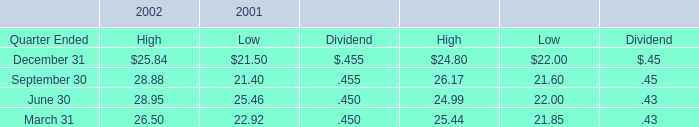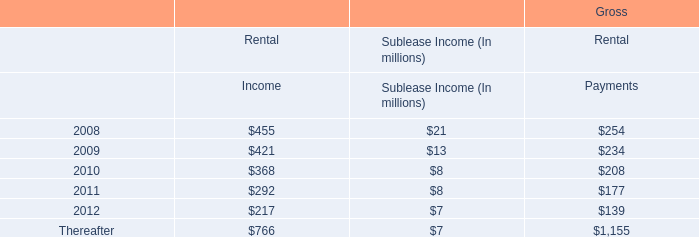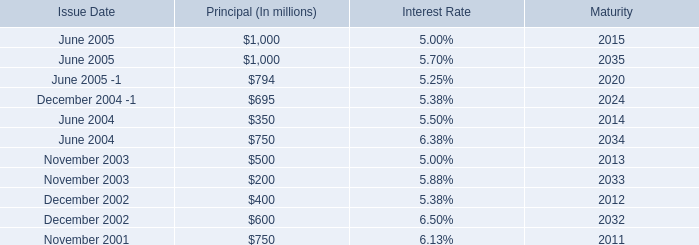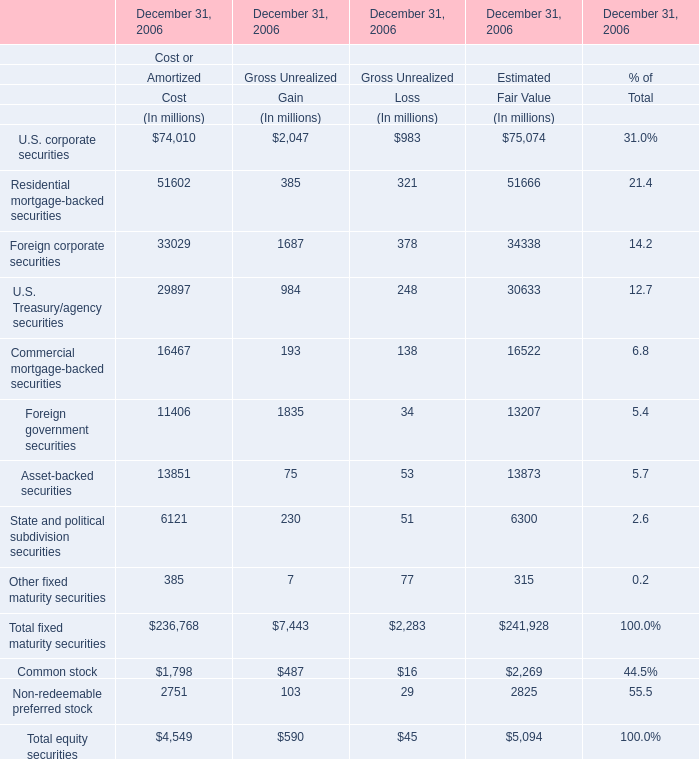What's the greatest value of U.S. corporate securities in 2006? (in million) 
Computations: (((74010 + 2047) + 983) + 75074)
Answer: 152114.0. 